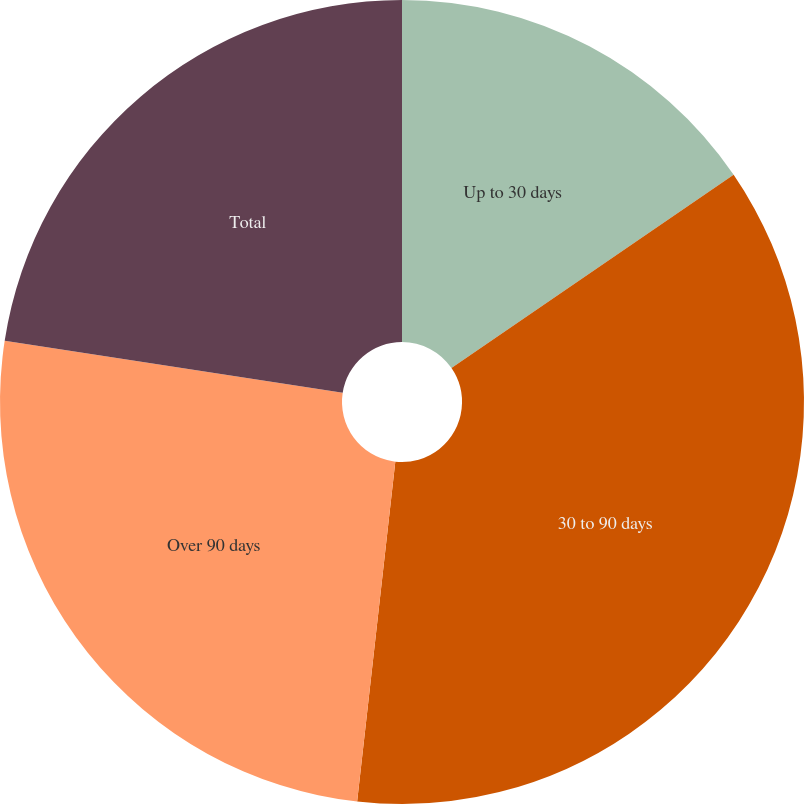<chart> <loc_0><loc_0><loc_500><loc_500><pie_chart><fcel>Up to 30 days<fcel>30 to 90 days<fcel>Over 90 days<fcel>Total<nl><fcel>15.44%<fcel>36.34%<fcel>25.65%<fcel>22.57%<nl></chart> 